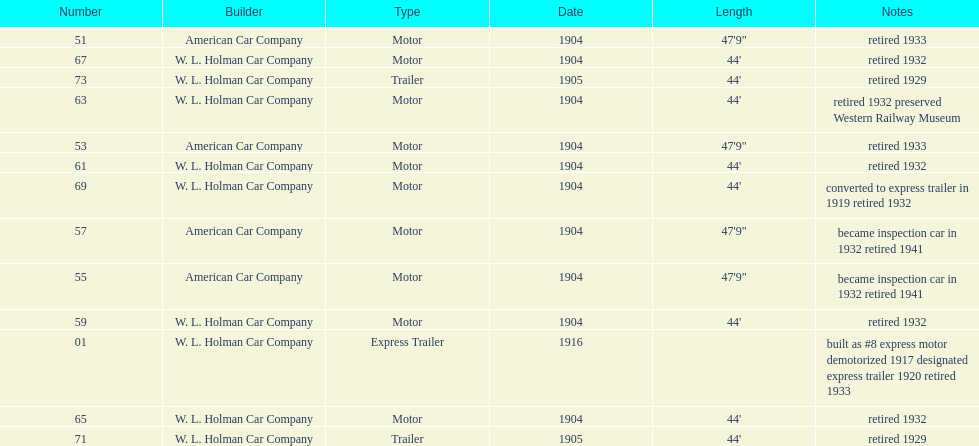Did american car company or w.l. holman car company build cars that were 44' in length? W. L. Holman Car Company. 